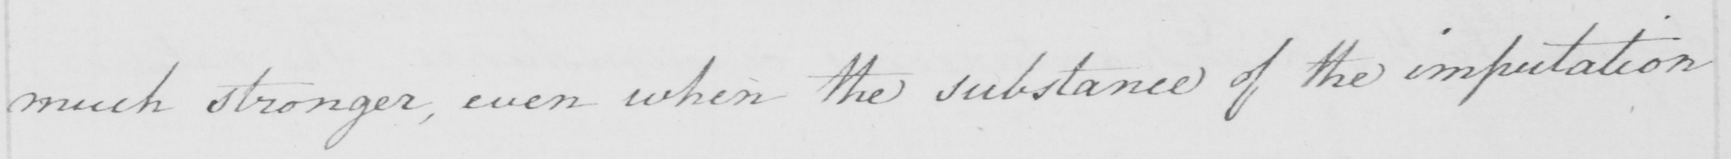Please provide the text content of this handwritten line. much stronger , even when the substance of the imputation 